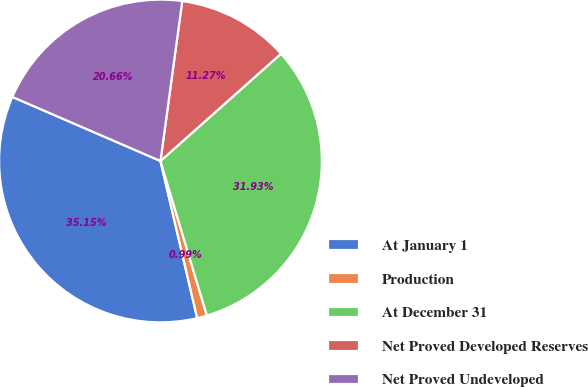Convert chart to OTSL. <chart><loc_0><loc_0><loc_500><loc_500><pie_chart><fcel>At January 1<fcel>Production<fcel>At December 31<fcel>Net Proved Developed Reserves<fcel>Net Proved Undeveloped<nl><fcel>35.15%<fcel>0.99%<fcel>31.93%<fcel>11.27%<fcel>20.66%<nl></chart> 